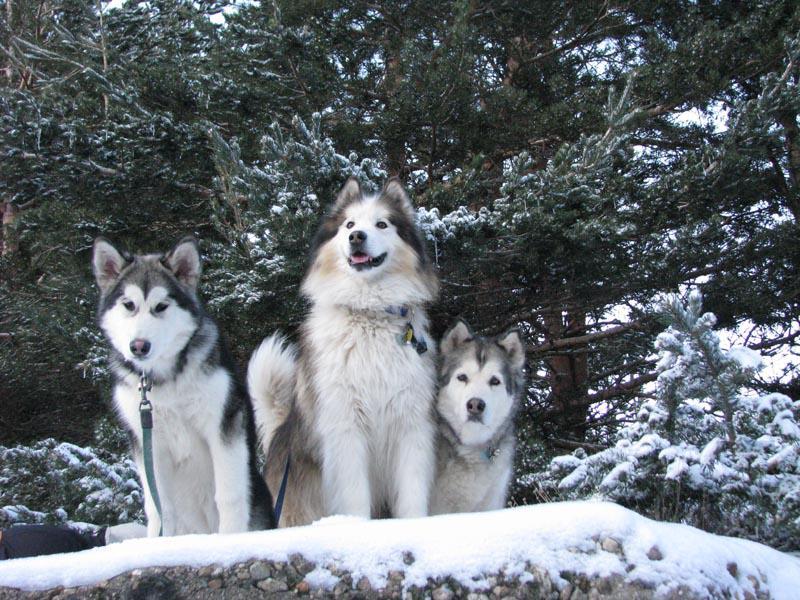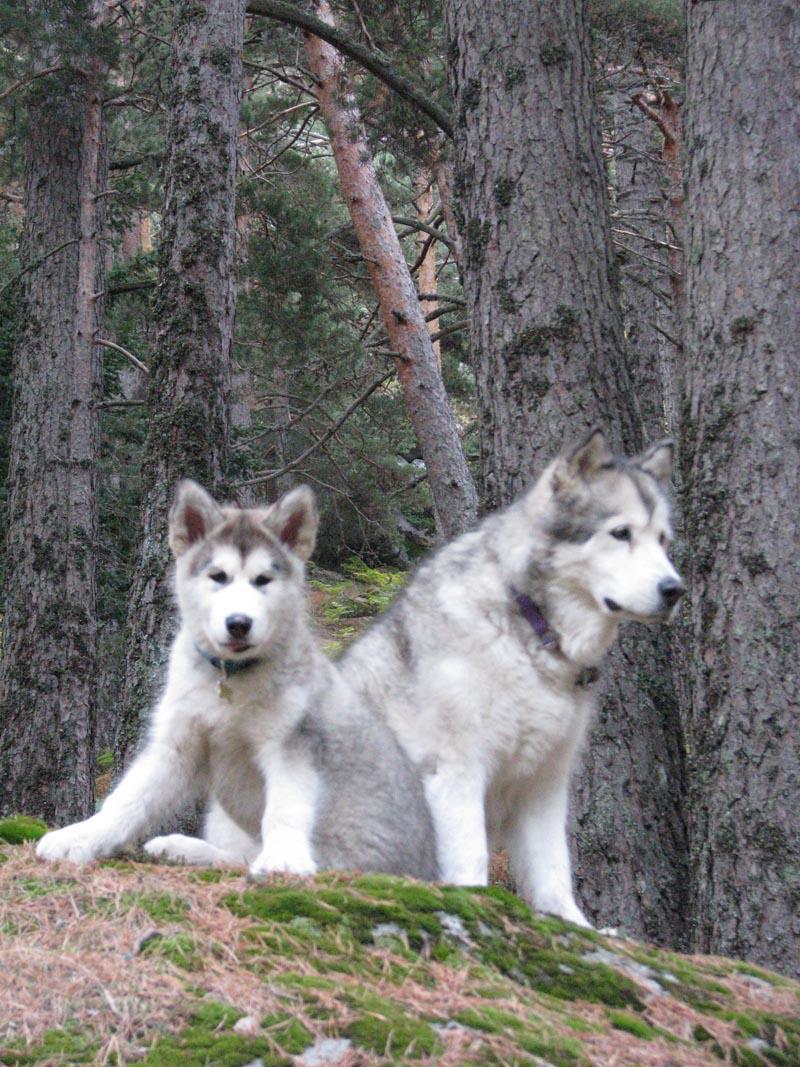The first image is the image on the left, the second image is the image on the right. Considering the images on both sides, is "At least one photo has two dogs, and at least three dogs have their mouths open." valid? Answer yes or no. No. The first image is the image on the left, the second image is the image on the right. Given the left and right images, does the statement "In one of the images, two malamutes are sitting in the grass." hold true? Answer yes or no. Yes. 